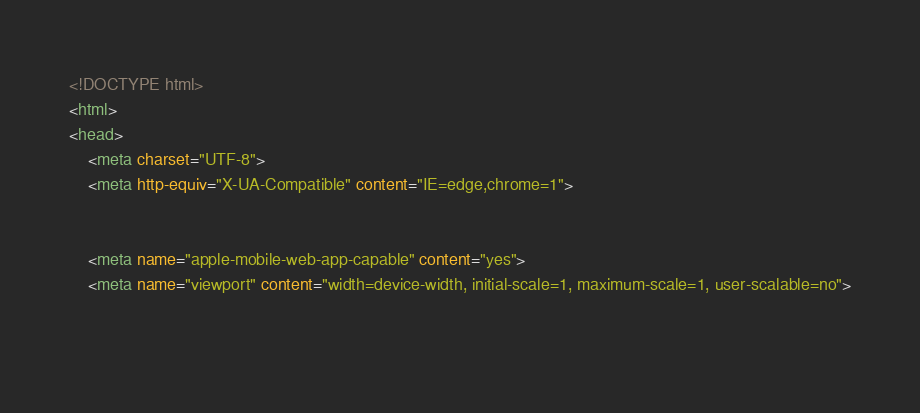Convert code to text. <code><loc_0><loc_0><loc_500><loc_500><_HTML_><!DOCTYPE html>
<html>
<head>
    <meta charset="UTF-8">
    <meta http-equiv="X-UA-Compatible" content="IE=edge,chrome=1">

    
    <meta name="apple-mobile-web-app-capable" content="yes">
    <meta name="viewport" content="width=device-width, initial-scale=1, maximum-scale=1, user-scalable=no">

    </code> 